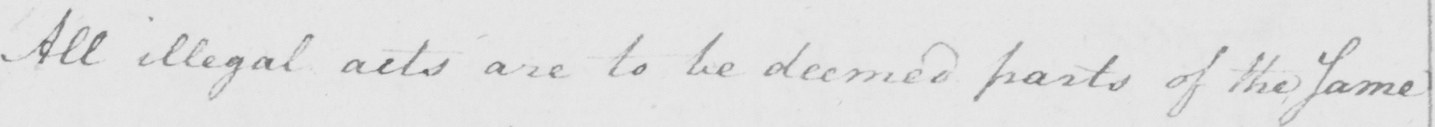What text is written in this handwritten line? All illegal acts are to be deemed parts of the Same 